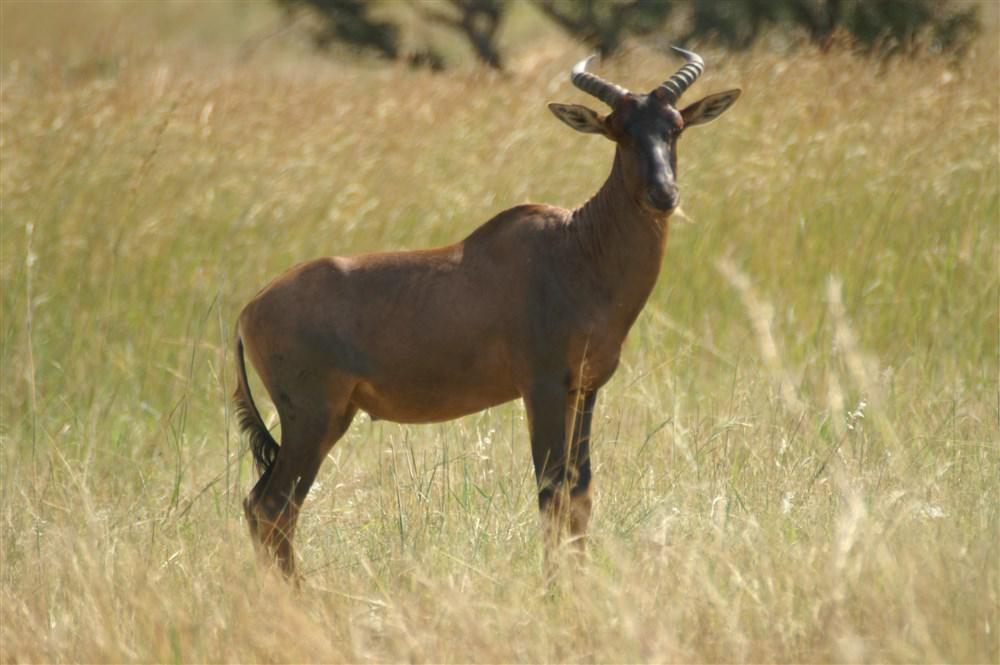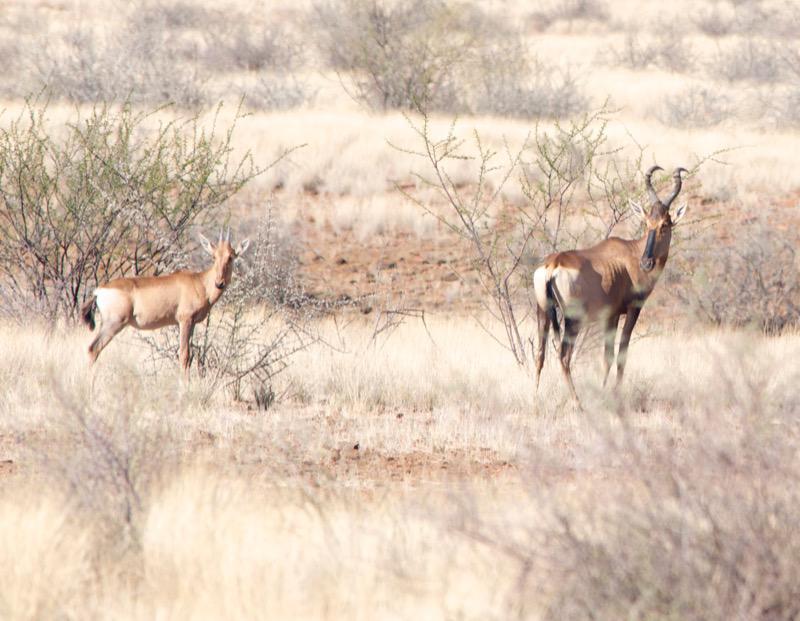The first image is the image on the left, the second image is the image on the right. Analyze the images presented: Is the assertion "The left and right image contains the same number of elk." valid? Answer yes or no. No. The first image is the image on the left, the second image is the image on the right. Assess this claim about the two images: "One image contains one horned animal standing with its body aimed rightward and its face turned forwards, and the other image includes a horned animal with its rear to the camera.". Correct or not? Answer yes or no. Yes. 